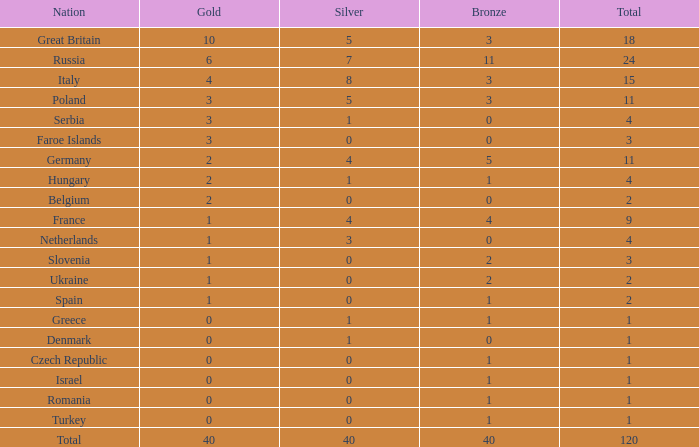What is the mean gold entry for the netherlands that additionally has a bronze entry higher than 0? None. 